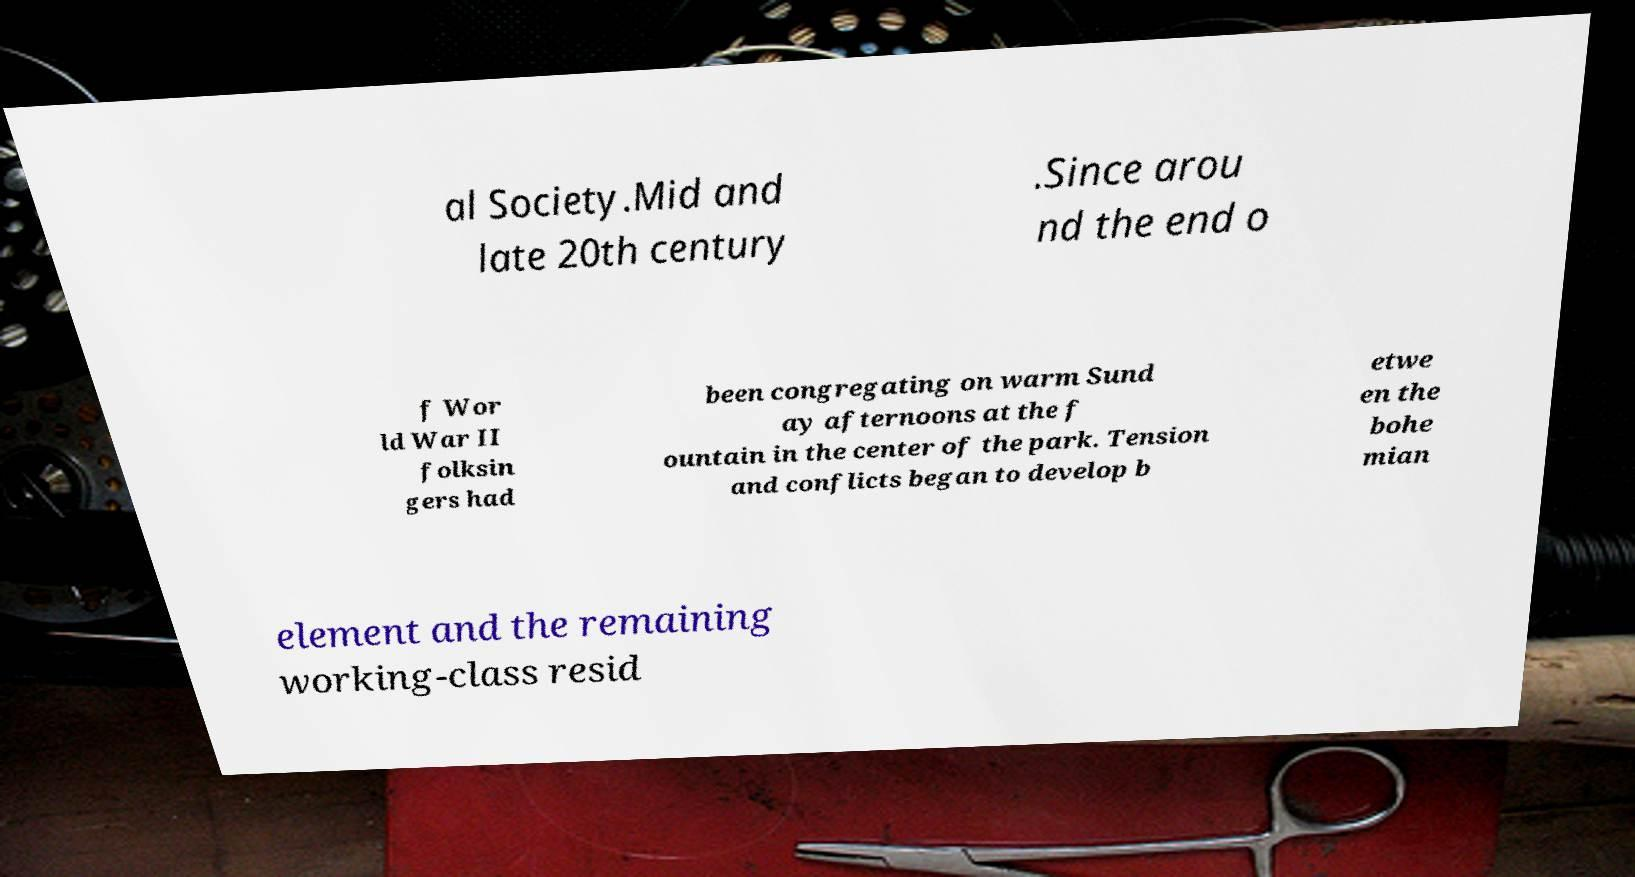Could you extract and type out the text from this image? al Society.Mid and late 20th century .Since arou nd the end o f Wor ld War II folksin gers had been congregating on warm Sund ay afternoons at the f ountain in the center of the park. Tension and conflicts began to develop b etwe en the bohe mian element and the remaining working-class resid 